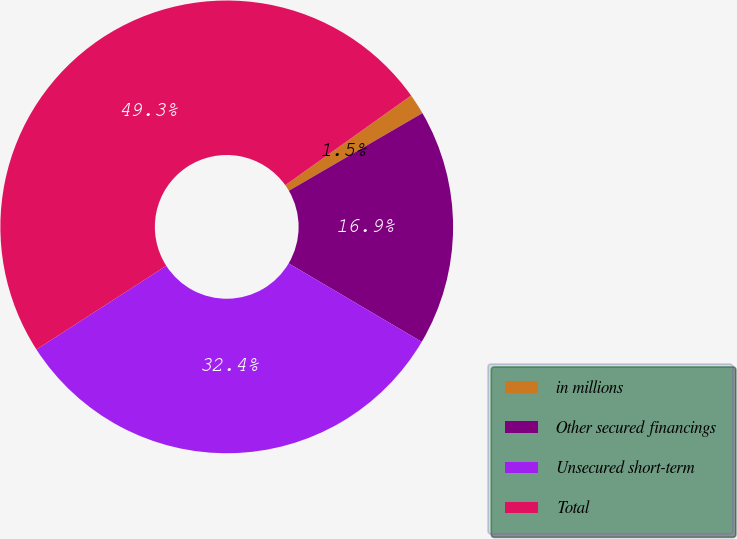Convert chart to OTSL. <chart><loc_0><loc_0><loc_500><loc_500><pie_chart><fcel>in millions<fcel>Other secured financings<fcel>Unsecured short-term<fcel>Total<nl><fcel>1.47%<fcel>16.86%<fcel>32.41%<fcel>49.26%<nl></chart> 